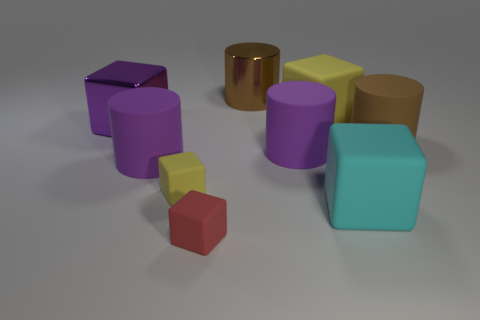The matte cylinder that is the same color as the large shiny cylinder is what size?
Your answer should be compact. Large. There is a metal object on the right side of the big purple cube; is its color the same as the large matte cylinder that is left of the brown metal cylinder?
Offer a very short reply. No. How many objects are tiny brown metal blocks or big brown matte objects?
Your response must be concise. 1. How many other things are the same shape as the cyan rubber object?
Offer a very short reply. 4. Do the large brown cylinder left of the large cyan rubber cube and the purple cylinder that is left of the large brown metallic cylinder have the same material?
Make the answer very short. No. There is a thing that is both to the left of the tiny red matte cube and behind the brown rubber thing; what is its shape?
Provide a short and direct response. Cube. There is a block that is on the left side of the tiny red rubber thing and in front of the brown rubber thing; what is its material?
Make the answer very short. Rubber. The brown thing that is the same material as the red cube is what shape?
Provide a succinct answer. Cylinder. Are there any other things that have the same color as the big metal cylinder?
Provide a succinct answer. Yes. Is the number of large purple rubber objects behind the large cyan object greater than the number of large yellow rubber things?
Make the answer very short. Yes. 